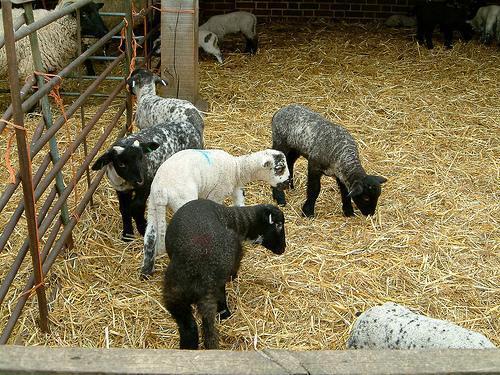How many sheep?
Give a very brief answer. 9. How many sheep are drinking water?
Give a very brief answer. 0. How many white sheep are there in the image?
Give a very brief answer. 1. How many white sheeps are there in this image?
Give a very brief answer. 3. 